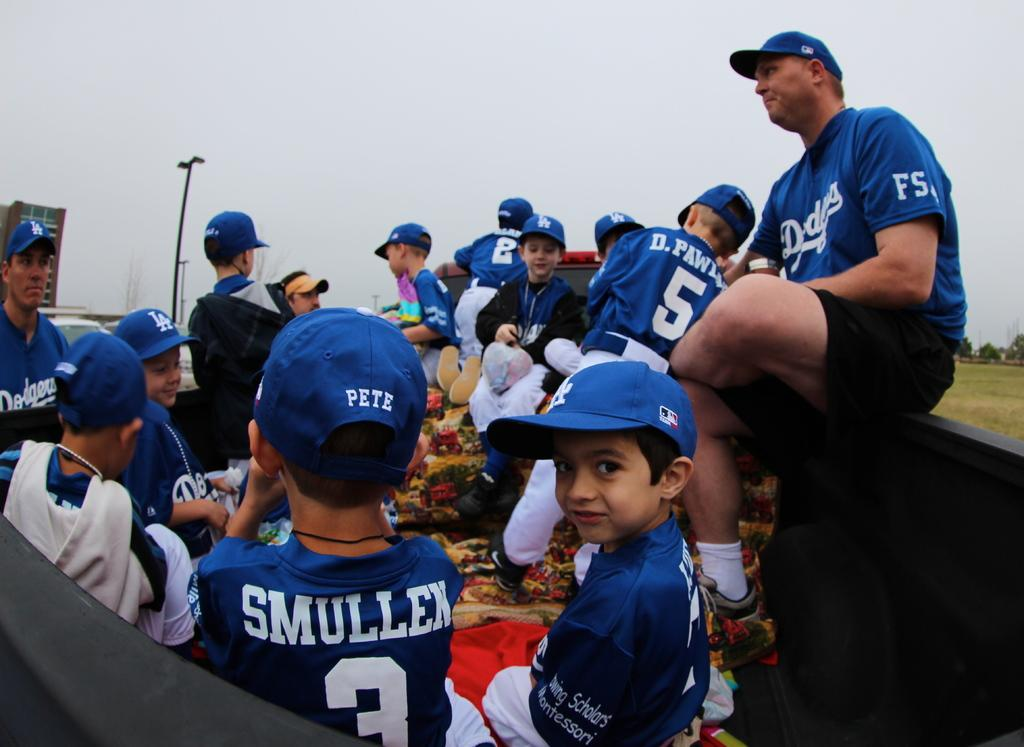<image>
Give a short and clear explanation of the subsequent image. A bunch of people are at a dodgers baseball game. 